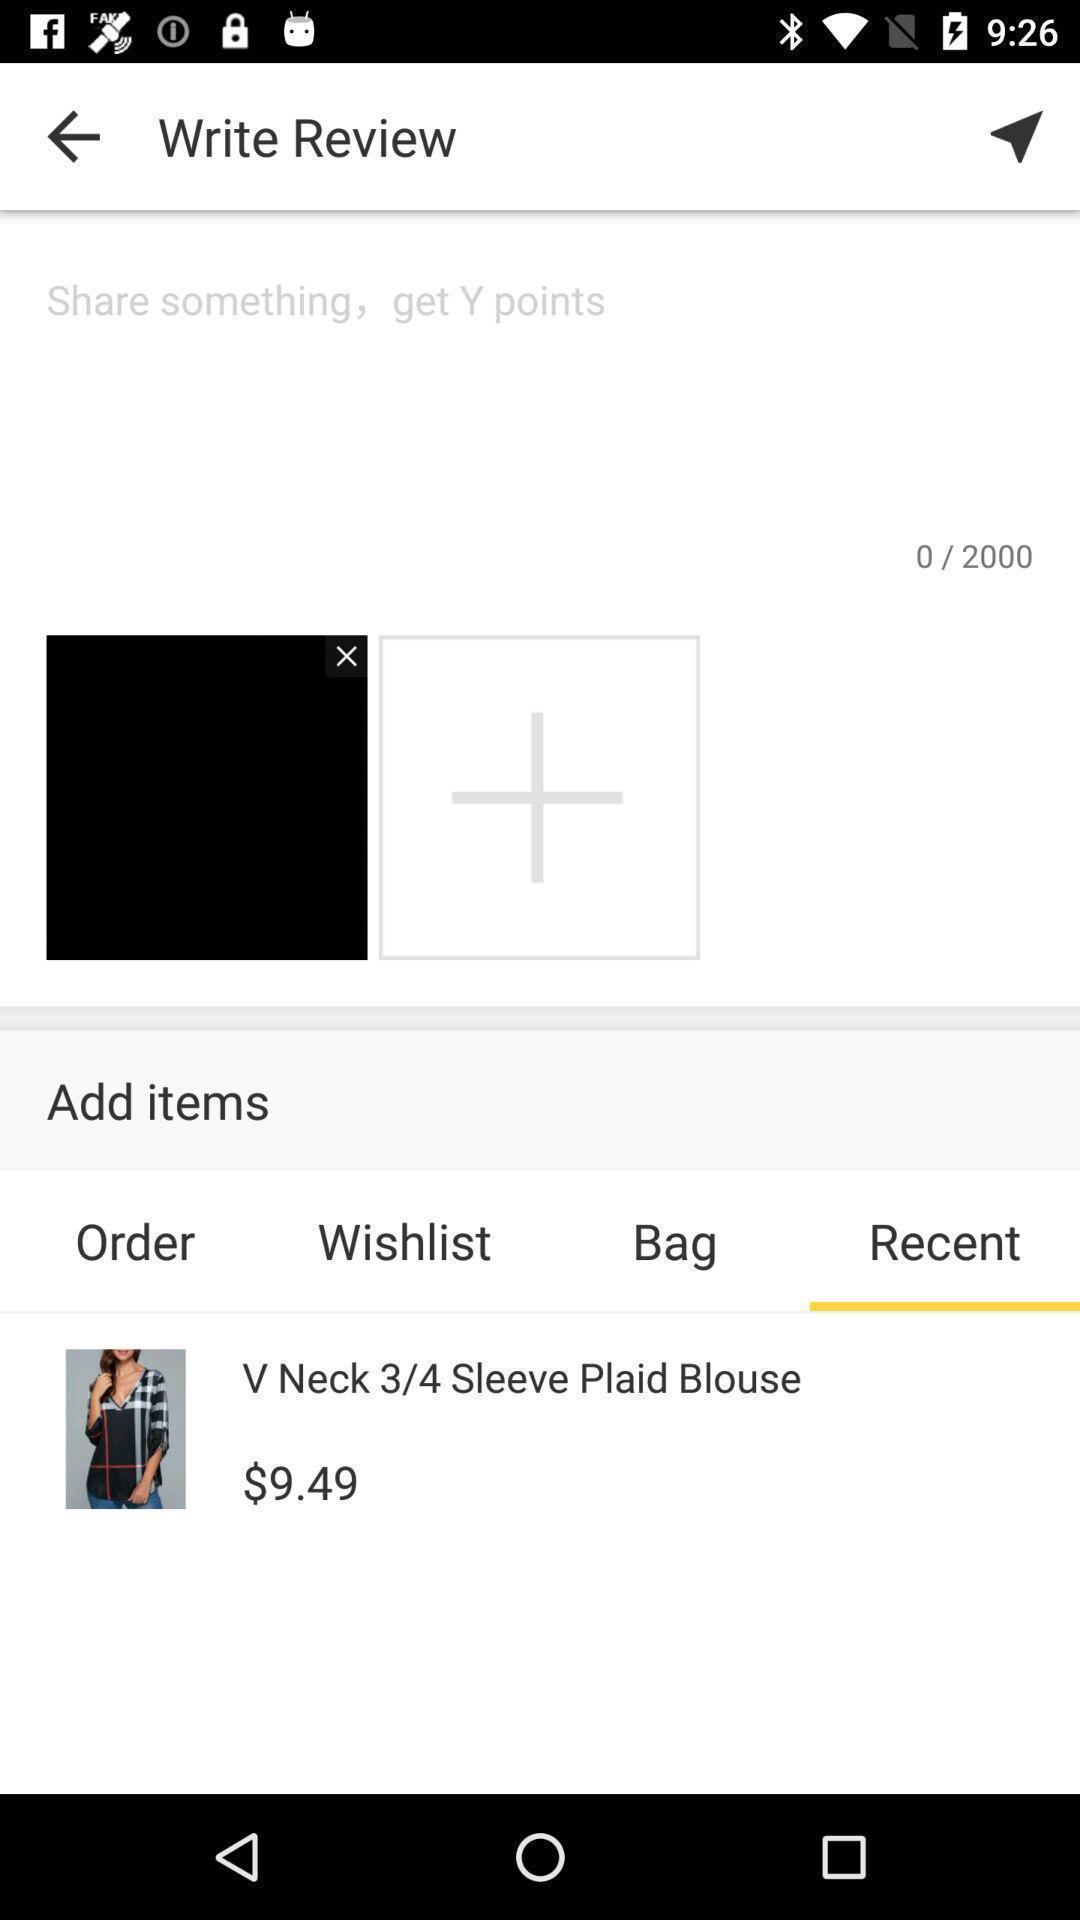Give me a summary of this screen capture. Screen shows to write a review in a shopping app. 